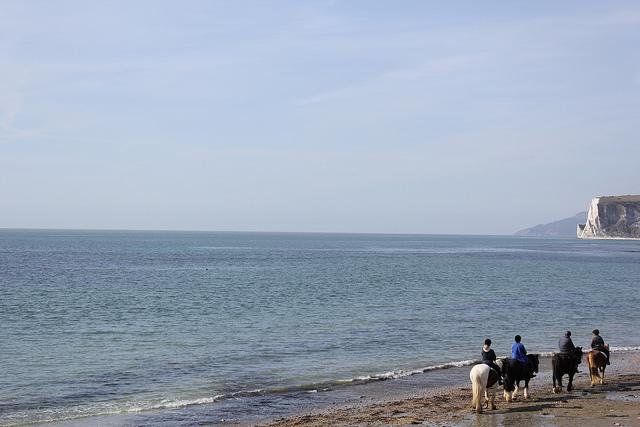What is the first terrain on the right? Please explain your reasoning. cliff. In the distance behind the water to the right we see the topology defining a cliff. 